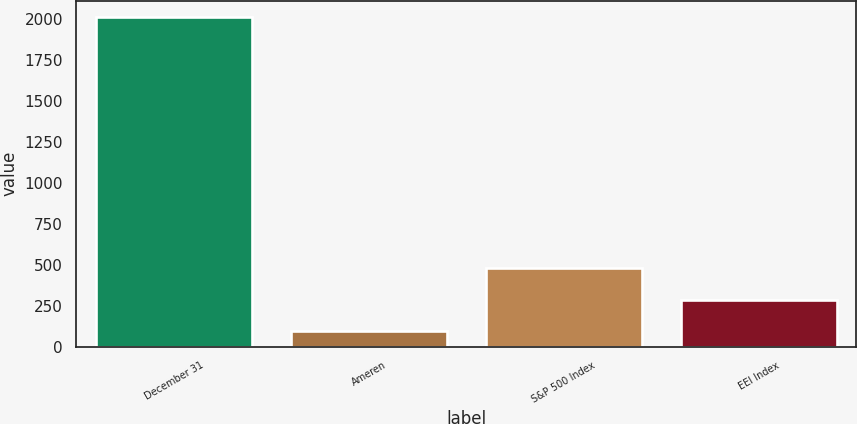Convert chart. <chart><loc_0><loc_0><loc_500><loc_500><bar_chart><fcel>December 31<fcel>Ameren<fcel>S&P 500 Index<fcel>EEI Index<nl><fcel>2010<fcel>95.41<fcel>478.33<fcel>286.87<nl></chart> 